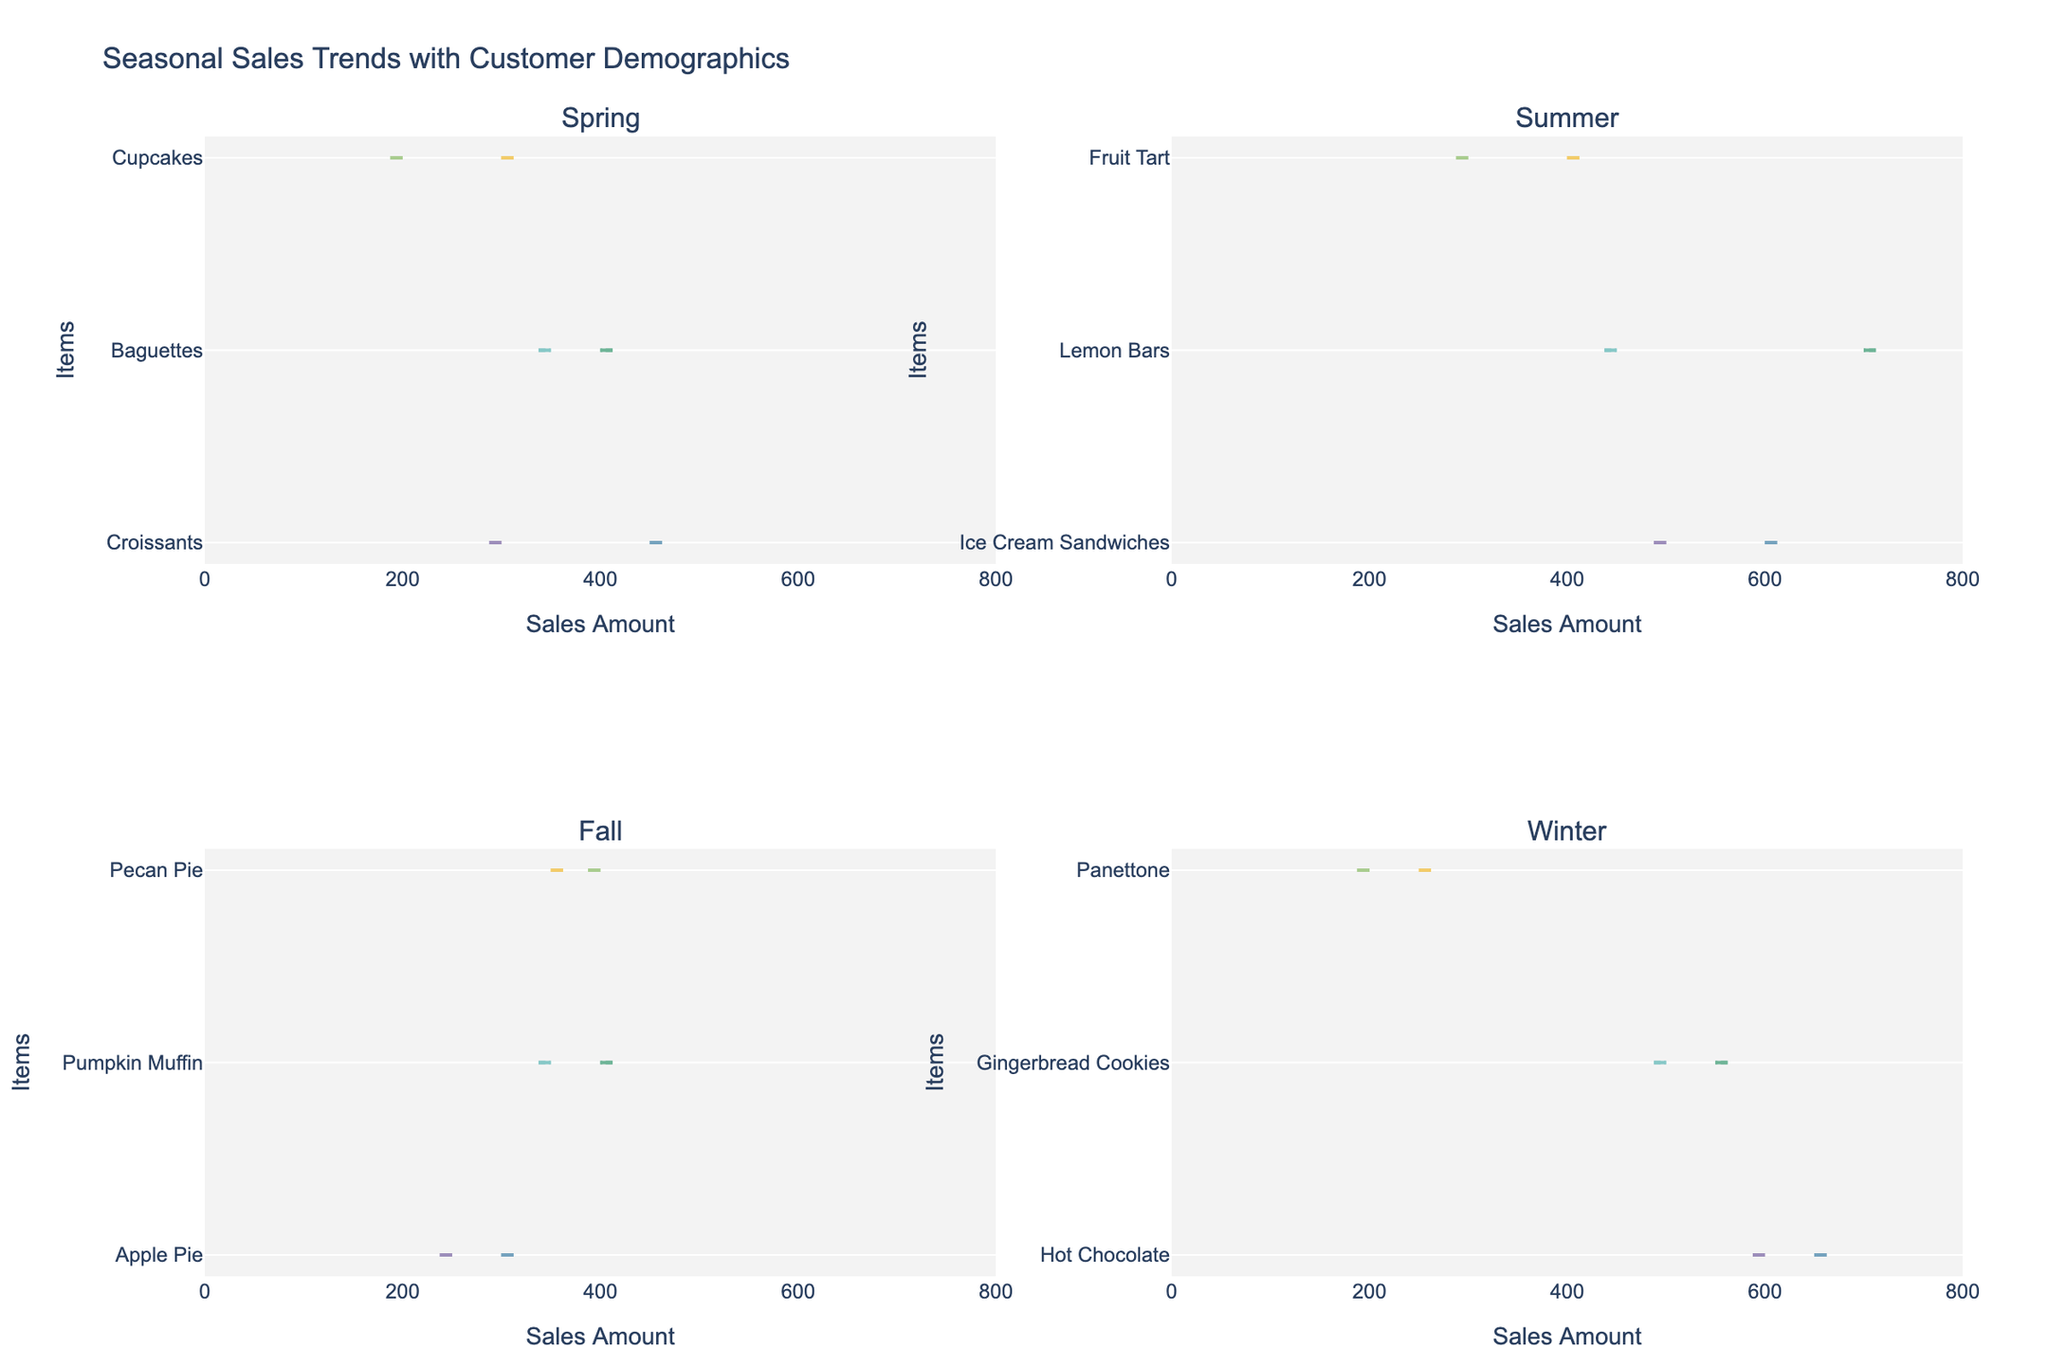What kinds of items are included in the Summer season sales? Look for the titles or labels associated with the Summer season subplots, and identify the names of items included.
Answer: Ice Cream Sandwiches, Lemon Bars, Fruit Tart What is the average sales amount for Male customers buying Croissants in Spring? Observe the Split Violin for Croissants in the Spring season subplot. Extract the sales data for Male customers, which is centered around 300.
Answer: 300 Which item has the highest sales amount for Female customers in Winter? In the Winter subplot, compare the violin plots for Female customers. Locate the item with the highest sales peak, which is centered around Hot Chocolate at 650.
Answer: Hot Chocolate How does the sales amount distribution for Male customers' Lemon Bars in Summer compare to Female customers? Notice the width and spread of the violins for Lemon Bars in the Summer subplot. The Female customers' violin is broader and centered higher (around 700) compared to Male (around 450).
Answer: Female sales are higher and more spread out What is the sales difference between Pecan Pie and Pumpkin Muffin for Female customers in Fall? Locate the Fall subplot and compare median sales amounts. Extract the data points (Pecan Pie ~350, Pumpkin Muffin ~400) and calculate difference 400 - 350.
Answer: 50 For which season do Female customers have consistently higher sales amounts than Male customers? Assess each potential split violin plot across all seasons to see if Female distributions are always higher. This pattern consistently occurs in Summer.
Answer: Summer What is the most popular item for Male customers in Winter in terms of sales amount? Evaluate the October subplot for Winter season and compare the Male distributions: Hot Chocolate has the largest peak (600).
Answer: Hot Chocolate Which item shows the least gender difference in sales amount for Winter? In the Winter subplot, check the alignment and overlap of Male and Female violin plots. Gingerbread Cookies show nearly equally centered sales amounts (500 vs. 550).
Answer: Gingerbread Cookies 